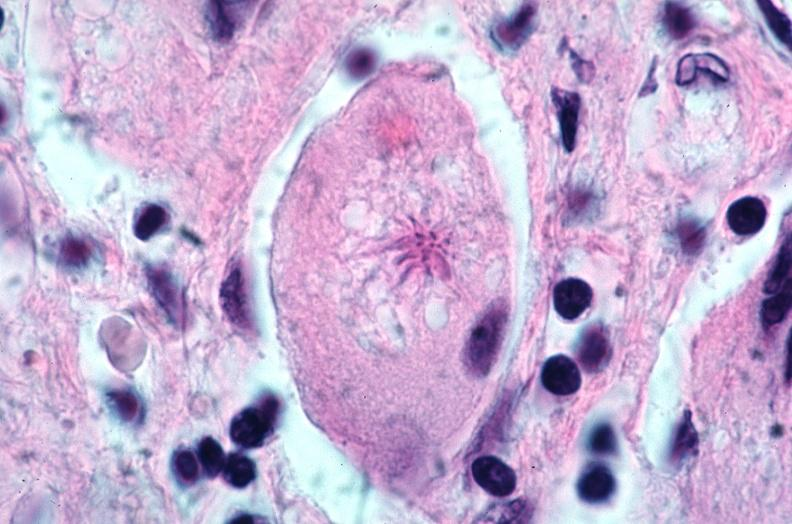s respiratory present?
Answer the question using a single word or phrase. Yes 